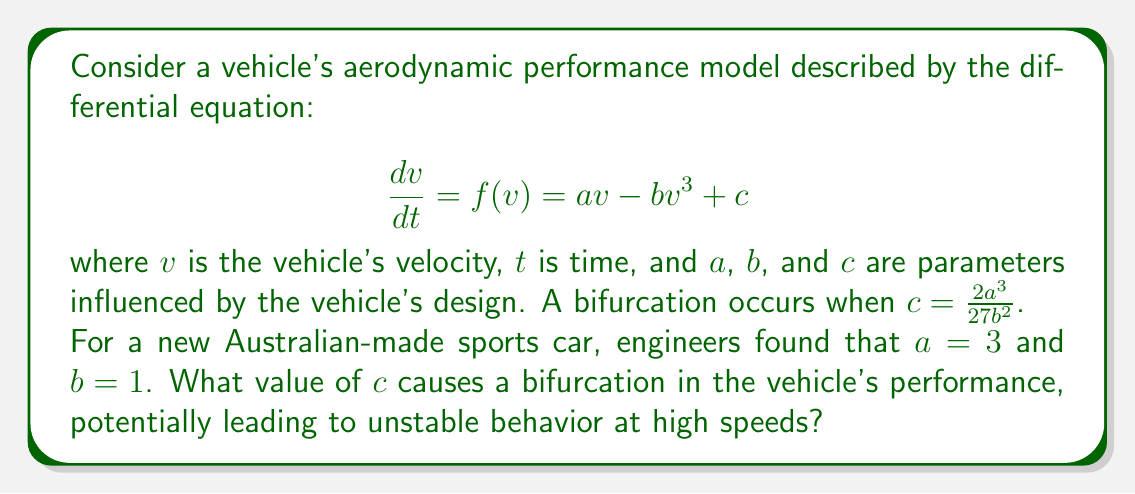What is the answer to this math problem? To solve this problem, we'll follow these steps:

1) We're given the general condition for bifurcation:
   $$c = \frac{2a^3}{27b^2}$$

2) We're also given the specific values for $a$ and $b$:
   $a = 3$
   $b = 1$

3) Let's substitute these values into the bifurcation condition:
   $$c = \frac{2(3)^3}{27(1)^2}$$

4) Simplify the numerator:
   $$c = \frac{2(27)}{27(1)}$$

5) Cancel out common factors:
   $$c = \frac{54}{27} = 2$$

Therefore, when $c = 2$, a bifurcation occurs in the vehicle's performance model.

This bifurcation point represents a critical change in the system's behavior. For values of $c$ below 2, the system might have one stable equilibrium. At $c = 2$, the system undergoes a saddle-node bifurcation, and for $c > 2$, the system might have three equilibria (two stable and one unstable), potentially leading to more complex and possibly unstable behavior at high speeds.
Answer: $c = 2$ 